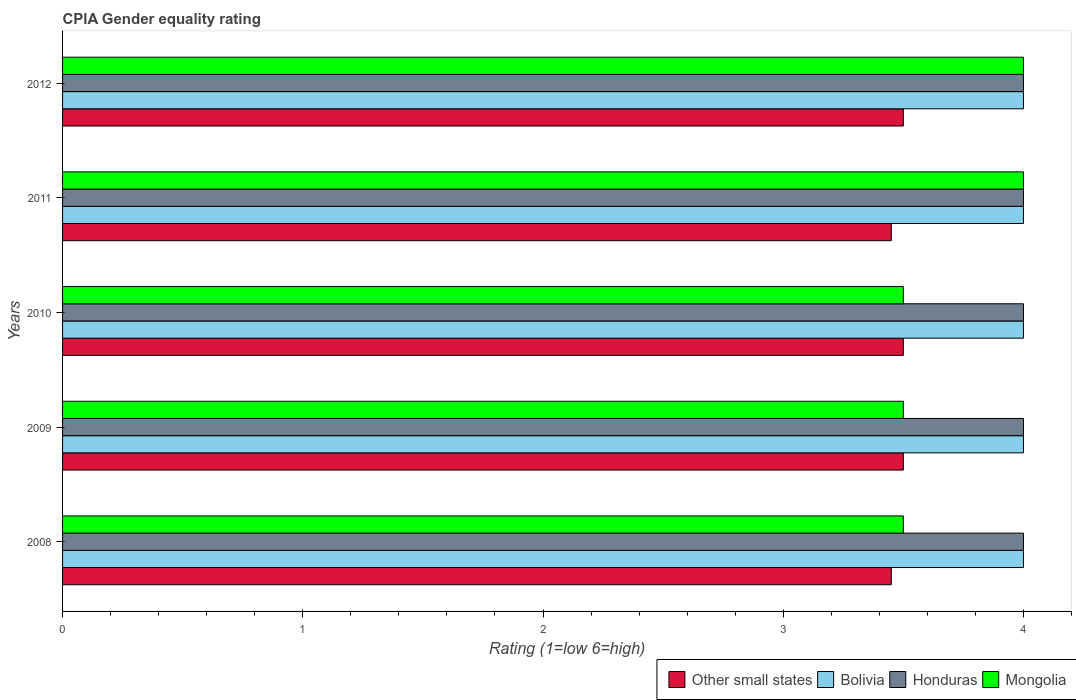How many different coloured bars are there?
Your answer should be compact. 4. How many groups of bars are there?
Your answer should be very brief. 5. Are the number of bars per tick equal to the number of legend labels?
Ensure brevity in your answer.  Yes. What is the label of the 2nd group of bars from the top?
Provide a succinct answer. 2011. What is the CPIA rating in Mongolia in 2010?
Ensure brevity in your answer.  3.5. Across all years, what is the maximum CPIA rating in Mongolia?
Offer a very short reply. 4. In which year was the CPIA rating in Bolivia minimum?
Your answer should be compact. 2008. What is the average CPIA rating in Other small states per year?
Make the answer very short. 3.48. In the year 2010, what is the difference between the CPIA rating in Bolivia and CPIA rating in Honduras?
Provide a short and direct response. 0. Is the difference between the CPIA rating in Bolivia in 2008 and 2009 greater than the difference between the CPIA rating in Honduras in 2008 and 2009?
Your answer should be compact. No. In how many years, is the CPIA rating in Mongolia greater than the average CPIA rating in Mongolia taken over all years?
Give a very brief answer. 2. Is the sum of the CPIA rating in Mongolia in 2008 and 2012 greater than the maximum CPIA rating in Bolivia across all years?
Provide a succinct answer. Yes. Is it the case that in every year, the sum of the CPIA rating in Other small states and CPIA rating in Bolivia is greater than the sum of CPIA rating in Honduras and CPIA rating in Mongolia?
Your answer should be compact. No. What does the 4th bar from the bottom in 2012 represents?
Give a very brief answer. Mongolia. How many years are there in the graph?
Provide a short and direct response. 5. Are the values on the major ticks of X-axis written in scientific E-notation?
Offer a terse response. No. How many legend labels are there?
Make the answer very short. 4. What is the title of the graph?
Your response must be concise. CPIA Gender equality rating. What is the label or title of the Y-axis?
Keep it short and to the point. Years. What is the Rating (1=low 6=high) in Other small states in 2008?
Provide a succinct answer. 3.45. What is the Rating (1=low 6=high) in Bolivia in 2009?
Keep it short and to the point. 4. What is the Rating (1=low 6=high) of Other small states in 2010?
Give a very brief answer. 3.5. What is the Rating (1=low 6=high) in Bolivia in 2010?
Your answer should be very brief. 4. What is the Rating (1=low 6=high) of Other small states in 2011?
Make the answer very short. 3.45. What is the Rating (1=low 6=high) in Other small states in 2012?
Provide a short and direct response. 3.5. What is the Rating (1=low 6=high) of Honduras in 2012?
Keep it short and to the point. 4. What is the Rating (1=low 6=high) of Mongolia in 2012?
Your answer should be compact. 4. Across all years, what is the maximum Rating (1=low 6=high) of Bolivia?
Ensure brevity in your answer.  4. Across all years, what is the maximum Rating (1=low 6=high) of Honduras?
Offer a very short reply. 4. Across all years, what is the maximum Rating (1=low 6=high) in Mongolia?
Provide a short and direct response. 4. Across all years, what is the minimum Rating (1=low 6=high) of Other small states?
Your answer should be very brief. 3.45. What is the total Rating (1=low 6=high) of Bolivia in the graph?
Offer a very short reply. 20. What is the total Rating (1=low 6=high) in Mongolia in the graph?
Provide a short and direct response. 18.5. What is the difference between the Rating (1=low 6=high) in Other small states in 2008 and that in 2009?
Give a very brief answer. -0.05. What is the difference between the Rating (1=low 6=high) of Mongolia in 2008 and that in 2009?
Your answer should be compact. 0. What is the difference between the Rating (1=low 6=high) in Other small states in 2008 and that in 2010?
Make the answer very short. -0.05. What is the difference between the Rating (1=low 6=high) in Mongolia in 2008 and that in 2010?
Make the answer very short. 0. What is the difference between the Rating (1=low 6=high) of Bolivia in 2008 and that in 2011?
Ensure brevity in your answer.  0. What is the difference between the Rating (1=low 6=high) in Mongolia in 2008 and that in 2011?
Keep it short and to the point. -0.5. What is the difference between the Rating (1=low 6=high) in Other small states in 2008 and that in 2012?
Make the answer very short. -0.05. What is the difference between the Rating (1=low 6=high) in Bolivia in 2008 and that in 2012?
Make the answer very short. 0. What is the difference between the Rating (1=low 6=high) of Mongolia in 2008 and that in 2012?
Keep it short and to the point. -0.5. What is the difference between the Rating (1=low 6=high) of Other small states in 2009 and that in 2010?
Your answer should be compact. 0. What is the difference between the Rating (1=low 6=high) of Bolivia in 2009 and that in 2010?
Keep it short and to the point. 0. What is the difference between the Rating (1=low 6=high) of Mongolia in 2009 and that in 2010?
Provide a short and direct response. 0. What is the difference between the Rating (1=low 6=high) of Other small states in 2009 and that in 2011?
Ensure brevity in your answer.  0.05. What is the difference between the Rating (1=low 6=high) in Mongolia in 2009 and that in 2011?
Make the answer very short. -0.5. What is the difference between the Rating (1=low 6=high) in Honduras in 2009 and that in 2012?
Provide a short and direct response. 0. What is the difference between the Rating (1=low 6=high) in Mongolia in 2009 and that in 2012?
Offer a terse response. -0.5. What is the difference between the Rating (1=low 6=high) in Honduras in 2010 and that in 2011?
Provide a short and direct response. 0. What is the difference between the Rating (1=low 6=high) in Bolivia in 2010 and that in 2012?
Your answer should be very brief. 0. What is the difference between the Rating (1=low 6=high) of Honduras in 2010 and that in 2012?
Your answer should be very brief. 0. What is the difference between the Rating (1=low 6=high) of Bolivia in 2011 and that in 2012?
Your answer should be compact. 0. What is the difference between the Rating (1=low 6=high) of Mongolia in 2011 and that in 2012?
Provide a short and direct response. 0. What is the difference between the Rating (1=low 6=high) of Other small states in 2008 and the Rating (1=low 6=high) of Bolivia in 2009?
Offer a terse response. -0.55. What is the difference between the Rating (1=low 6=high) in Other small states in 2008 and the Rating (1=low 6=high) in Honduras in 2009?
Give a very brief answer. -0.55. What is the difference between the Rating (1=low 6=high) in Other small states in 2008 and the Rating (1=low 6=high) in Mongolia in 2009?
Make the answer very short. -0.05. What is the difference between the Rating (1=low 6=high) of Bolivia in 2008 and the Rating (1=low 6=high) of Honduras in 2009?
Offer a terse response. 0. What is the difference between the Rating (1=low 6=high) in Honduras in 2008 and the Rating (1=low 6=high) in Mongolia in 2009?
Offer a terse response. 0.5. What is the difference between the Rating (1=low 6=high) of Other small states in 2008 and the Rating (1=low 6=high) of Bolivia in 2010?
Give a very brief answer. -0.55. What is the difference between the Rating (1=low 6=high) in Other small states in 2008 and the Rating (1=low 6=high) in Honduras in 2010?
Provide a short and direct response. -0.55. What is the difference between the Rating (1=low 6=high) of Honduras in 2008 and the Rating (1=low 6=high) of Mongolia in 2010?
Ensure brevity in your answer.  0.5. What is the difference between the Rating (1=low 6=high) in Other small states in 2008 and the Rating (1=low 6=high) in Bolivia in 2011?
Your response must be concise. -0.55. What is the difference between the Rating (1=low 6=high) in Other small states in 2008 and the Rating (1=low 6=high) in Honduras in 2011?
Provide a short and direct response. -0.55. What is the difference between the Rating (1=low 6=high) of Other small states in 2008 and the Rating (1=low 6=high) of Mongolia in 2011?
Your answer should be very brief. -0.55. What is the difference between the Rating (1=low 6=high) of Other small states in 2008 and the Rating (1=low 6=high) of Bolivia in 2012?
Provide a succinct answer. -0.55. What is the difference between the Rating (1=low 6=high) in Other small states in 2008 and the Rating (1=low 6=high) in Honduras in 2012?
Your answer should be very brief. -0.55. What is the difference between the Rating (1=low 6=high) of Other small states in 2008 and the Rating (1=low 6=high) of Mongolia in 2012?
Offer a terse response. -0.55. What is the difference between the Rating (1=low 6=high) of Other small states in 2009 and the Rating (1=low 6=high) of Honduras in 2010?
Your answer should be compact. -0.5. What is the difference between the Rating (1=low 6=high) of Other small states in 2009 and the Rating (1=low 6=high) of Honduras in 2011?
Your response must be concise. -0.5. What is the difference between the Rating (1=low 6=high) of Bolivia in 2009 and the Rating (1=low 6=high) of Mongolia in 2011?
Offer a terse response. 0. What is the difference between the Rating (1=low 6=high) of Other small states in 2009 and the Rating (1=low 6=high) of Bolivia in 2012?
Ensure brevity in your answer.  -0.5. What is the difference between the Rating (1=low 6=high) in Bolivia in 2009 and the Rating (1=low 6=high) in Mongolia in 2012?
Ensure brevity in your answer.  0. What is the difference between the Rating (1=low 6=high) in Honduras in 2009 and the Rating (1=low 6=high) in Mongolia in 2012?
Provide a succinct answer. 0. What is the difference between the Rating (1=low 6=high) in Other small states in 2010 and the Rating (1=low 6=high) in Bolivia in 2011?
Your answer should be compact. -0.5. What is the difference between the Rating (1=low 6=high) of Other small states in 2010 and the Rating (1=low 6=high) of Mongolia in 2011?
Make the answer very short. -0.5. What is the difference between the Rating (1=low 6=high) in Honduras in 2010 and the Rating (1=low 6=high) in Mongolia in 2011?
Offer a very short reply. 0. What is the difference between the Rating (1=low 6=high) in Other small states in 2010 and the Rating (1=low 6=high) in Honduras in 2012?
Ensure brevity in your answer.  -0.5. What is the difference between the Rating (1=low 6=high) in Bolivia in 2010 and the Rating (1=low 6=high) in Mongolia in 2012?
Your answer should be compact. 0. What is the difference between the Rating (1=low 6=high) in Other small states in 2011 and the Rating (1=low 6=high) in Bolivia in 2012?
Keep it short and to the point. -0.55. What is the difference between the Rating (1=low 6=high) in Other small states in 2011 and the Rating (1=low 6=high) in Honduras in 2012?
Provide a short and direct response. -0.55. What is the difference between the Rating (1=low 6=high) of Other small states in 2011 and the Rating (1=low 6=high) of Mongolia in 2012?
Give a very brief answer. -0.55. What is the difference between the Rating (1=low 6=high) in Bolivia in 2011 and the Rating (1=low 6=high) in Honduras in 2012?
Your answer should be compact. 0. What is the average Rating (1=low 6=high) in Other small states per year?
Give a very brief answer. 3.48. What is the average Rating (1=low 6=high) of Mongolia per year?
Keep it short and to the point. 3.7. In the year 2008, what is the difference between the Rating (1=low 6=high) of Other small states and Rating (1=low 6=high) of Bolivia?
Your response must be concise. -0.55. In the year 2008, what is the difference between the Rating (1=low 6=high) of Other small states and Rating (1=low 6=high) of Honduras?
Your response must be concise. -0.55. In the year 2008, what is the difference between the Rating (1=low 6=high) of Other small states and Rating (1=low 6=high) of Mongolia?
Your answer should be compact. -0.05. In the year 2008, what is the difference between the Rating (1=low 6=high) in Bolivia and Rating (1=low 6=high) in Honduras?
Your response must be concise. 0. In the year 2008, what is the difference between the Rating (1=low 6=high) in Bolivia and Rating (1=low 6=high) in Mongolia?
Make the answer very short. 0.5. In the year 2009, what is the difference between the Rating (1=low 6=high) of Other small states and Rating (1=low 6=high) of Honduras?
Your answer should be very brief. -0.5. In the year 2009, what is the difference between the Rating (1=low 6=high) of Bolivia and Rating (1=low 6=high) of Mongolia?
Offer a very short reply. 0.5. In the year 2009, what is the difference between the Rating (1=low 6=high) of Honduras and Rating (1=low 6=high) of Mongolia?
Ensure brevity in your answer.  0.5. In the year 2010, what is the difference between the Rating (1=low 6=high) of Other small states and Rating (1=low 6=high) of Honduras?
Your response must be concise. -0.5. In the year 2010, what is the difference between the Rating (1=low 6=high) in Bolivia and Rating (1=low 6=high) in Honduras?
Make the answer very short. 0. In the year 2010, what is the difference between the Rating (1=low 6=high) in Bolivia and Rating (1=low 6=high) in Mongolia?
Offer a terse response. 0.5. In the year 2010, what is the difference between the Rating (1=low 6=high) in Honduras and Rating (1=low 6=high) in Mongolia?
Offer a very short reply. 0.5. In the year 2011, what is the difference between the Rating (1=low 6=high) of Other small states and Rating (1=low 6=high) of Bolivia?
Your answer should be compact. -0.55. In the year 2011, what is the difference between the Rating (1=low 6=high) in Other small states and Rating (1=low 6=high) in Honduras?
Give a very brief answer. -0.55. In the year 2011, what is the difference between the Rating (1=low 6=high) of Other small states and Rating (1=low 6=high) of Mongolia?
Offer a very short reply. -0.55. In the year 2012, what is the difference between the Rating (1=low 6=high) in Other small states and Rating (1=low 6=high) in Bolivia?
Ensure brevity in your answer.  -0.5. In the year 2012, what is the difference between the Rating (1=low 6=high) of Other small states and Rating (1=low 6=high) of Honduras?
Provide a short and direct response. -0.5. In the year 2012, what is the difference between the Rating (1=low 6=high) in Other small states and Rating (1=low 6=high) in Mongolia?
Make the answer very short. -0.5. In the year 2012, what is the difference between the Rating (1=low 6=high) in Bolivia and Rating (1=low 6=high) in Mongolia?
Provide a succinct answer. 0. What is the ratio of the Rating (1=low 6=high) in Other small states in 2008 to that in 2009?
Ensure brevity in your answer.  0.99. What is the ratio of the Rating (1=low 6=high) in Bolivia in 2008 to that in 2009?
Provide a succinct answer. 1. What is the ratio of the Rating (1=low 6=high) in Honduras in 2008 to that in 2009?
Make the answer very short. 1. What is the ratio of the Rating (1=low 6=high) of Other small states in 2008 to that in 2010?
Your answer should be very brief. 0.99. What is the ratio of the Rating (1=low 6=high) of Bolivia in 2008 to that in 2010?
Provide a short and direct response. 1. What is the ratio of the Rating (1=low 6=high) of Honduras in 2008 to that in 2010?
Your answer should be compact. 1. What is the ratio of the Rating (1=low 6=high) of Mongolia in 2008 to that in 2010?
Make the answer very short. 1. What is the ratio of the Rating (1=low 6=high) of Other small states in 2008 to that in 2011?
Your answer should be very brief. 1. What is the ratio of the Rating (1=low 6=high) of Honduras in 2008 to that in 2011?
Ensure brevity in your answer.  1. What is the ratio of the Rating (1=low 6=high) in Mongolia in 2008 to that in 2011?
Give a very brief answer. 0.88. What is the ratio of the Rating (1=low 6=high) in Other small states in 2008 to that in 2012?
Keep it short and to the point. 0.99. What is the ratio of the Rating (1=low 6=high) of Bolivia in 2008 to that in 2012?
Offer a very short reply. 1. What is the ratio of the Rating (1=low 6=high) in Honduras in 2009 to that in 2010?
Give a very brief answer. 1. What is the ratio of the Rating (1=low 6=high) of Mongolia in 2009 to that in 2010?
Provide a succinct answer. 1. What is the ratio of the Rating (1=low 6=high) of Other small states in 2009 to that in 2011?
Provide a short and direct response. 1.01. What is the ratio of the Rating (1=low 6=high) in Bolivia in 2009 to that in 2011?
Keep it short and to the point. 1. What is the ratio of the Rating (1=low 6=high) in Honduras in 2009 to that in 2012?
Provide a short and direct response. 1. What is the ratio of the Rating (1=low 6=high) in Other small states in 2010 to that in 2011?
Offer a terse response. 1.01. What is the ratio of the Rating (1=low 6=high) in Honduras in 2010 to that in 2011?
Your answer should be compact. 1. What is the ratio of the Rating (1=low 6=high) in Bolivia in 2010 to that in 2012?
Your answer should be compact. 1. What is the ratio of the Rating (1=low 6=high) in Mongolia in 2010 to that in 2012?
Provide a short and direct response. 0.88. What is the ratio of the Rating (1=low 6=high) of Other small states in 2011 to that in 2012?
Ensure brevity in your answer.  0.99. What is the ratio of the Rating (1=low 6=high) of Honduras in 2011 to that in 2012?
Make the answer very short. 1. What is the ratio of the Rating (1=low 6=high) in Mongolia in 2011 to that in 2012?
Provide a succinct answer. 1. What is the difference between the highest and the second highest Rating (1=low 6=high) of Other small states?
Offer a terse response. 0. What is the difference between the highest and the second highest Rating (1=low 6=high) in Honduras?
Your answer should be very brief. 0. What is the difference between the highest and the second highest Rating (1=low 6=high) in Mongolia?
Make the answer very short. 0. What is the difference between the highest and the lowest Rating (1=low 6=high) of Bolivia?
Your answer should be very brief. 0. What is the difference between the highest and the lowest Rating (1=low 6=high) of Honduras?
Your answer should be very brief. 0. What is the difference between the highest and the lowest Rating (1=low 6=high) of Mongolia?
Your answer should be very brief. 0.5. 